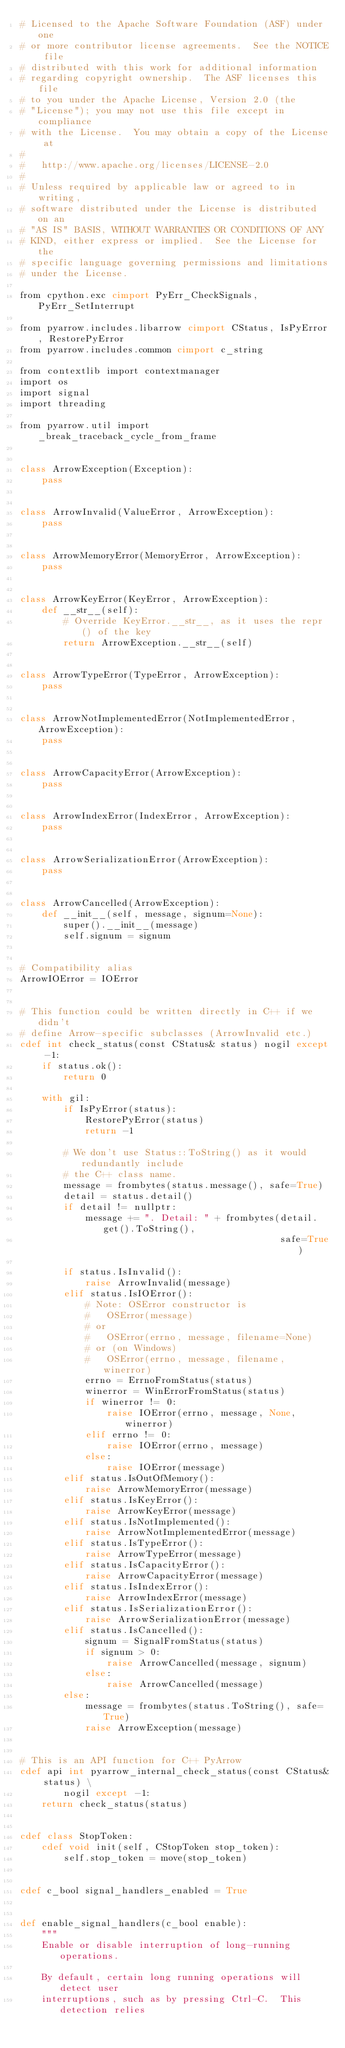Convert code to text. <code><loc_0><loc_0><loc_500><loc_500><_Cython_># Licensed to the Apache Software Foundation (ASF) under one
# or more contributor license agreements.  See the NOTICE file
# distributed with this work for additional information
# regarding copyright ownership.  The ASF licenses this file
# to you under the Apache License, Version 2.0 (the
# "License"); you may not use this file except in compliance
# with the License.  You may obtain a copy of the License at
#
#   http://www.apache.org/licenses/LICENSE-2.0
#
# Unless required by applicable law or agreed to in writing,
# software distributed under the License is distributed on an
# "AS IS" BASIS, WITHOUT WARRANTIES OR CONDITIONS OF ANY
# KIND, either express or implied.  See the License for the
# specific language governing permissions and limitations
# under the License.

from cpython.exc cimport PyErr_CheckSignals, PyErr_SetInterrupt

from pyarrow.includes.libarrow cimport CStatus, IsPyError, RestorePyError
from pyarrow.includes.common cimport c_string

from contextlib import contextmanager
import os
import signal
import threading

from pyarrow.util import _break_traceback_cycle_from_frame


class ArrowException(Exception):
    pass


class ArrowInvalid(ValueError, ArrowException):
    pass


class ArrowMemoryError(MemoryError, ArrowException):
    pass


class ArrowKeyError(KeyError, ArrowException):
    def __str__(self):
        # Override KeyError.__str__, as it uses the repr() of the key
        return ArrowException.__str__(self)


class ArrowTypeError(TypeError, ArrowException):
    pass


class ArrowNotImplementedError(NotImplementedError, ArrowException):
    pass


class ArrowCapacityError(ArrowException):
    pass


class ArrowIndexError(IndexError, ArrowException):
    pass


class ArrowSerializationError(ArrowException):
    pass


class ArrowCancelled(ArrowException):
    def __init__(self, message, signum=None):
        super().__init__(message)
        self.signum = signum


# Compatibility alias
ArrowIOError = IOError


# This function could be written directly in C++ if we didn't
# define Arrow-specific subclasses (ArrowInvalid etc.)
cdef int check_status(const CStatus& status) nogil except -1:
    if status.ok():
        return 0

    with gil:
        if IsPyError(status):
            RestorePyError(status)
            return -1

        # We don't use Status::ToString() as it would redundantly include
        # the C++ class name.
        message = frombytes(status.message(), safe=True)
        detail = status.detail()
        if detail != nullptr:
            message += ". Detail: " + frombytes(detail.get().ToString(),
                                                safe=True)

        if status.IsInvalid():
            raise ArrowInvalid(message)
        elif status.IsIOError():
            # Note: OSError constructor is
            #   OSError(message)
            # or
            #   OSError(errno, message, filename=None)
            # or (on Windows)
            #   OSError(errno, message, filename, winerror)
            errno = ErrnoFromStatus(status)
            winerror = WinErrorFromStatus(status)
            if winerror != 0:
                raise IOError(errno, message, None, winerror)
            elif errno != 0:
                raise IOError(errno, message)
            else:
                raise IOError(message)
        elif status.IsOutOfMemory():
            raise ArrowMemoryError(message)
        elif status.IsKeyError():
            raise ArrowKeyError(message)
        elif status.IsNotImplemented():
            raise ArrowNotImplementedError(message)
        elif status.IsTypeError():
            raise ArrowTypeError(message)
        elif status.IsCapacityError():
            raise ArrowCapacityError(message)
        elif status.IsIndexError():
            raise ArrowIndexError(message)
        elif status.IsSerializationError():
            raise ArrowSerializationError(message)
        elif status.IsCancelled():
            signum = SignalFromStatus(status)
            if signum > 0:
                raise ArrowCancelled(message, signum)
            else:
                raise ArrowCancelled(message)
        else:
            message = frombytes(status.ToString(), safe=True)
            raise ArrowException(message)


# This is an API function for C++ PyArrow
cdef api int pyarrow_internal_check_status(const CStatus& status) \
        nogil except -1:
    return check_status(status)


cdef class StopToken:
    cdef void init(self, CStopToken stop_token):
        self.stop_token = move(stop_token)


cdef c_bool signal_handlers_enabled = True


def enable_signal_handlers(c_bool enable):
    """
    Enable or disable interruption of long-running operations.

    By default, certain long running operations will detect user
    interruptions, such as by pressing Ctrl-C.  This detection relies</code> 